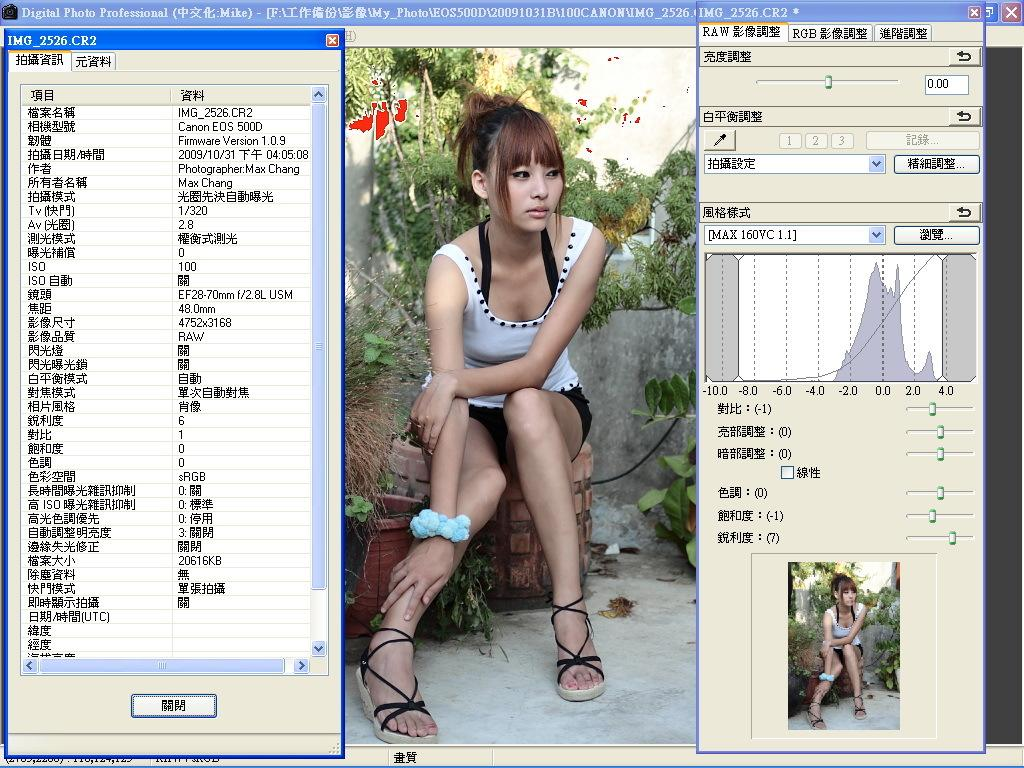What is the main subject of the image? The image contains a screenshot of a monitor. What can be seen within the screenshot? There is an image of a girl and some text in the screenshot. What type of horn can be seen in the image? There is no horn present in the image. How many oranges are visible in the image? There are no oranges visible in the image. 